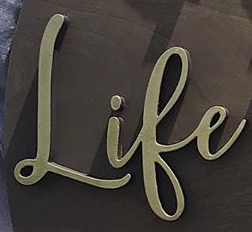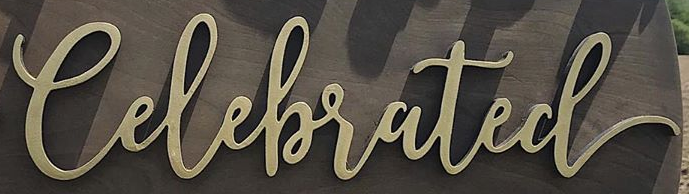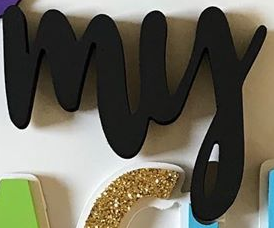Transcribe the words shown in these images in order, separated by a semicolon. Life; Celebrated; my 